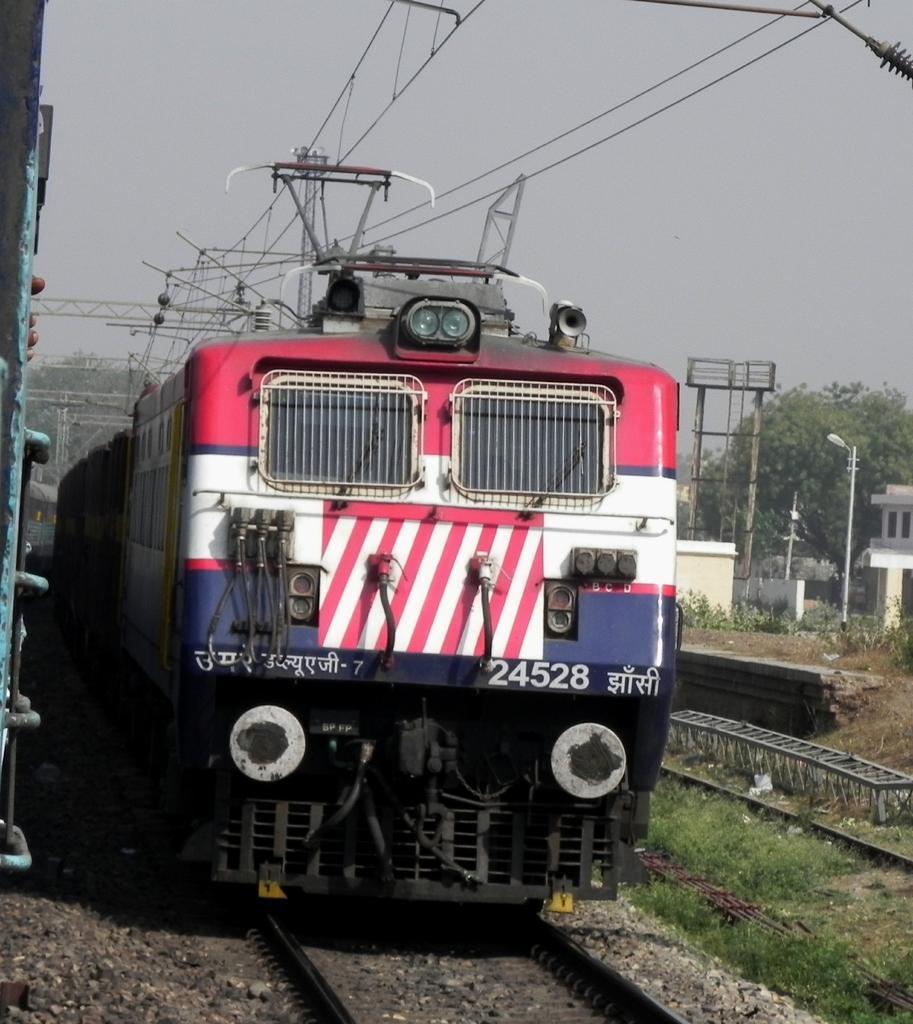How would you summarize this image in a sentence or two? In this picture we can see a train on a railway track, beside this train we can see a building, shed, trees, grass, electric poles and some objects and we can see sky in the background. 